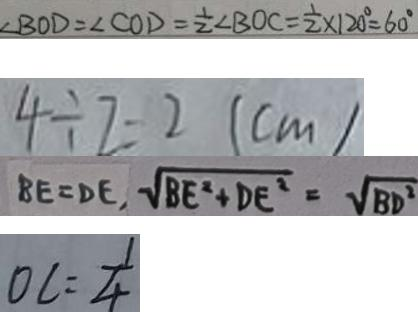<formula> <loc_0><loc_0><loc_500><loc_500>\angle B O D = \angle C O D = \frac { 1 } { 2 } \angle B O C = \frac { 1 } { 2 } \times 1 2 0 ^ { \circ } = 6 0 ^ { \circ } 
 4 \div 7 = 2 ( c m ) 
 B E = D E , \sqrt { B E ^ { 2 } + D E ^ { 2 } } = \sqrt { B D ^ { 2 } } 
 O C = \frac { 1 } { 4 }</formula> 